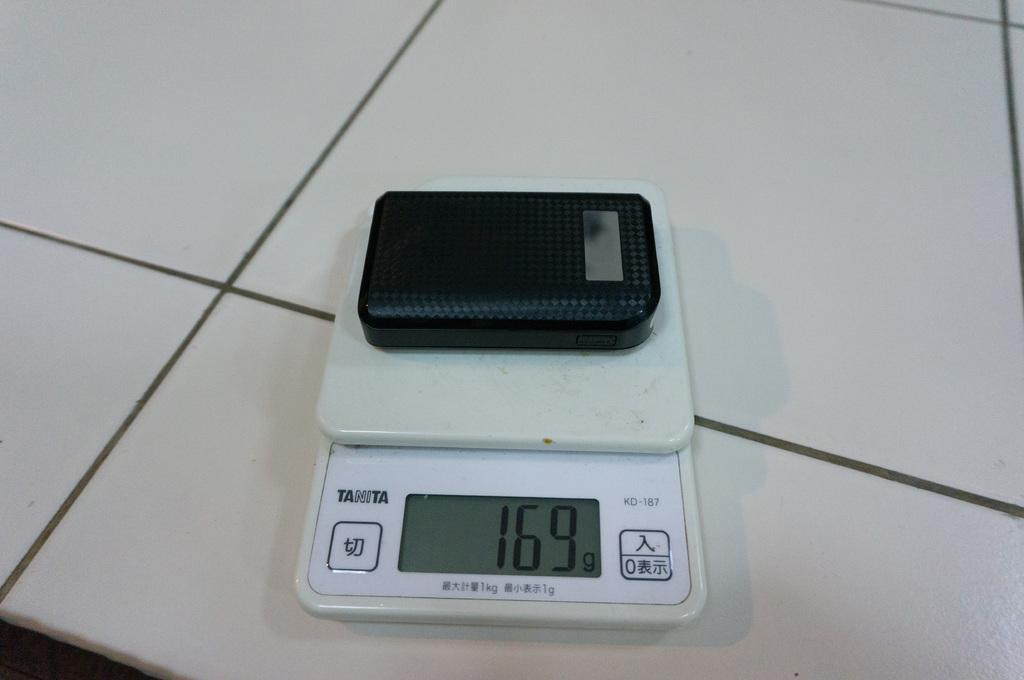<image>
Render a clear and concise summary of the photo. White Tanita electronic with one hundred and sixty nine on the screen. 